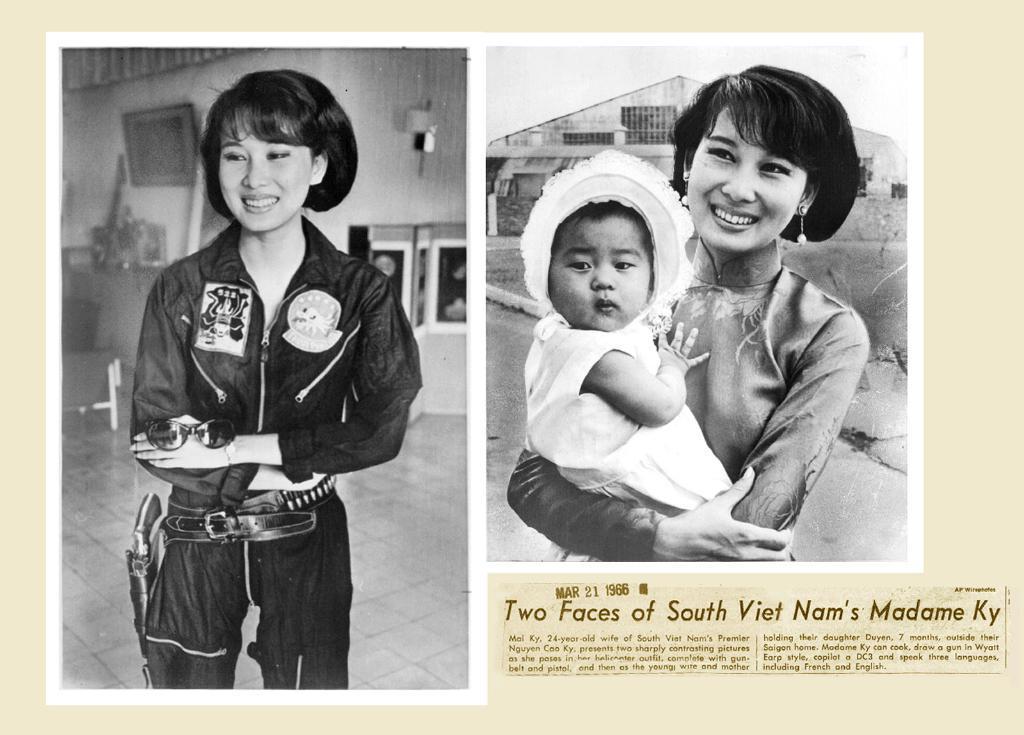Describe this image in one or two sentences. In this image there is a college, the first image there is a person standing, the second image there is a person standing and carrying another person, there is the text written on the image, there is a house behind the person, there is sky, there is the wall behind the person, there is a photo frame on the wall. 